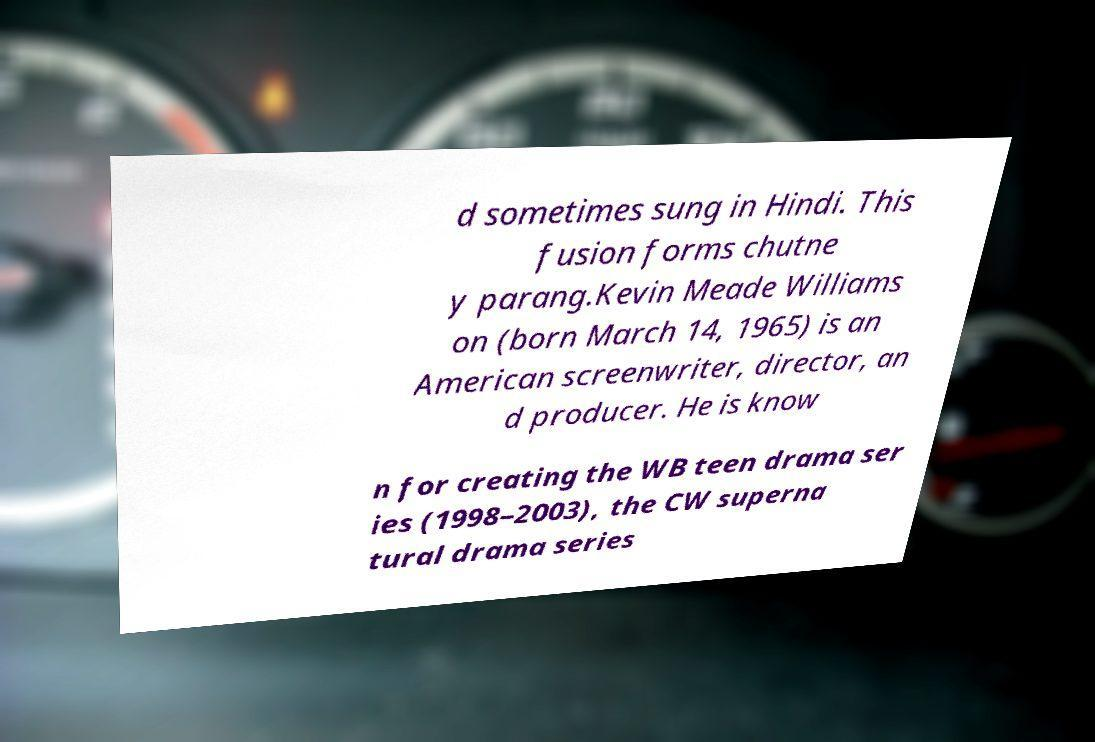There's text embedded in this image that I need extracted. Can you transcribe it verbatim? d sometimes sung in Hindi. This fusion forms chutne y parang.Kevin Meade Williams on (born March 14, 1965) is an American screenwriter, director, an d producer. He is know n for creating the WB teen drama ser ies (1998–2003), the CW superna tural drama series 